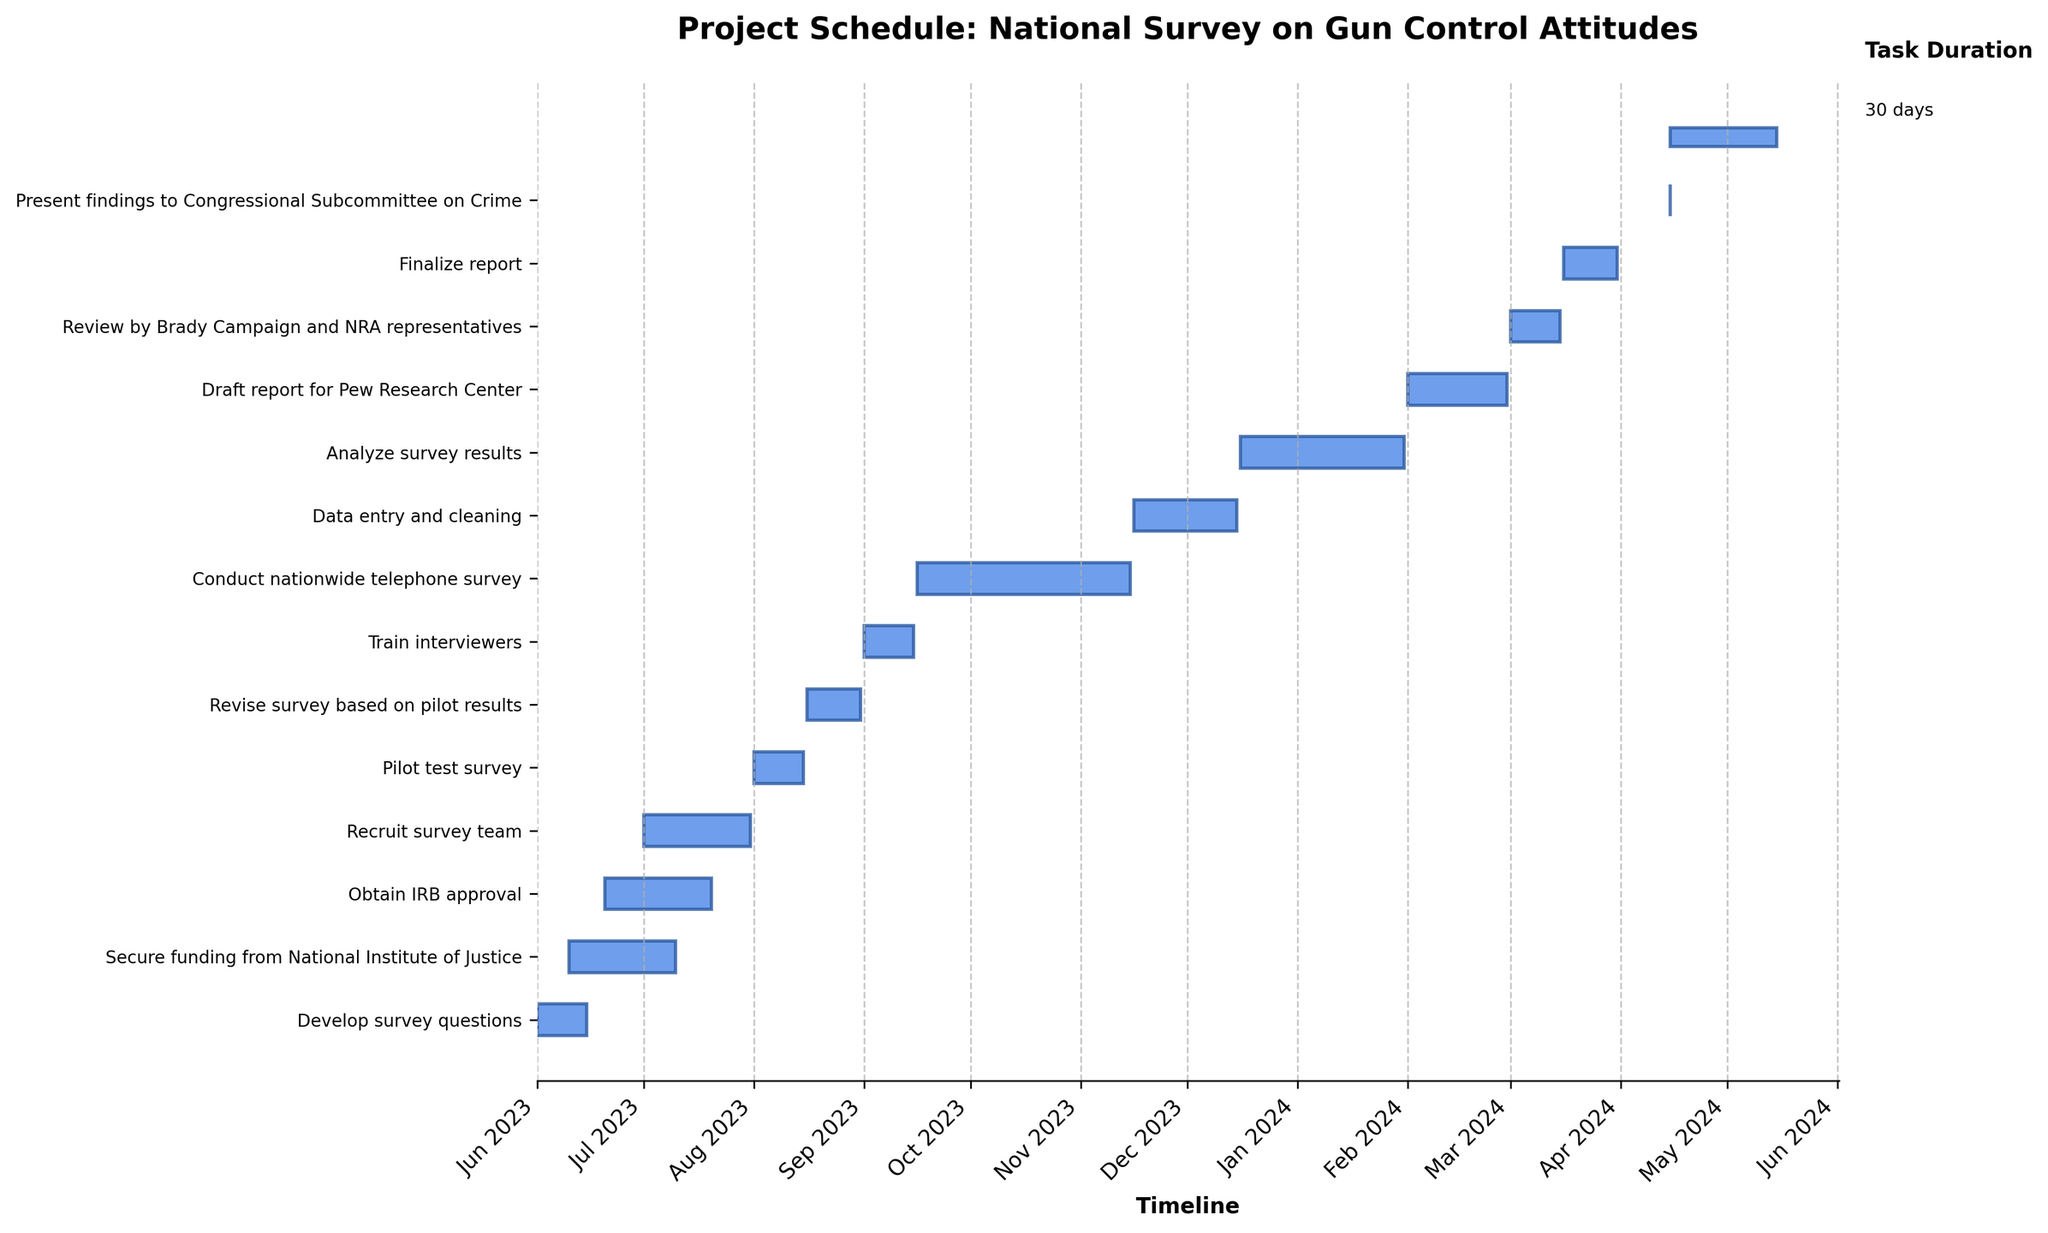What is the title of the Gantt Chart? The title is prominently displayed at the top of the chart. It reads "Project Schedule: National Survey on Gun Control Attitudes".
Answer: Project Schedule: National Survey on Gun Control Attitudes Which task appears to have the longest duration? By examining the horizontal bars, you can see that the "Conduct nationwide telephone survey" task, spanning from 2023-09-16 to 2023-11-15, has the longest bar indicating the longest duration.
Answer: Conduct nationwide telephone survey How many tasks are included in the project schedule? We can count the number of horizontal bars or the number of y-axis labels, which represent the tasks. There are 13 tasks in total.
Answer: 13 Which task's end date directly precedes the start of the "Conduct nationwide telephone survey"? Looking at the figure, the "Train interviewers" task ends on 2023-09-15, which is just before the start date of the "Conduct nationwide telephone survey" on 2023-09-16.
Answer: Train interviewers During which month does the "Analyze survey results" task end? By examining the timeline on the x-axis and the end date indicated for the "Analyze survey results" task, it ends in January 2024.
Answer: January 2024 Which tasks overlap with the "Obtain IRB approval" task? The "Obtain IRB approval" task runs from 2023-06-20 to 2023-07-20. Overlapping tasks include "Secure funding from National Institute of Justice" (2023-06-10 to 2023-07-10) and "Recruit survey team" (2023-07-01 to 2023-07-31).
Answer: Secure funding from National Institute of Justice, Recruit survey team What is the total duration of the "Pilot test survey" and "Revise survey based on pilot results" combined? The "Pilot test survey" runs for 15 days (from 2023-08-01 to 2023-08-15), and the "Revise survey based on pilot results" runs for 16 days (from 2023-08-16 to 2023-08-31). Combined, they last for 31 days.
Answer: 31 days When is the “Present findings to Congressional Subcommittee on Crime” scheduled? The schedule specifies that presenting the findings is a one-day event on 2024-04-15, as indicated by the end date being the same as the start date for this task.
Answer: 2024-04-15 Which task starts immediately after the "Revise survey based on pilot results"? By checking the timeline, the task "Train interviewers" starts immediately on 2023-09-01, right after the “Revise survey based on pilot results” ends on 2023-08-31.
Answer: Train interviewers How many tasks are scheduled to be completed by the end of 2023? Reviewing the end dates, the tasks completed by 2023-12-31 are "Develop survey questions", "Secure funding from National Institute of Justice", "Obtain IRB approval", "Recruit survey team", "Pilot test survey", "Revise survey based on pilot results", "Train interviewers", "Conduct nationwide telephone survey", and "Data entry and cleaning". This totals 9 tasks.
Answer: 9 tasks 